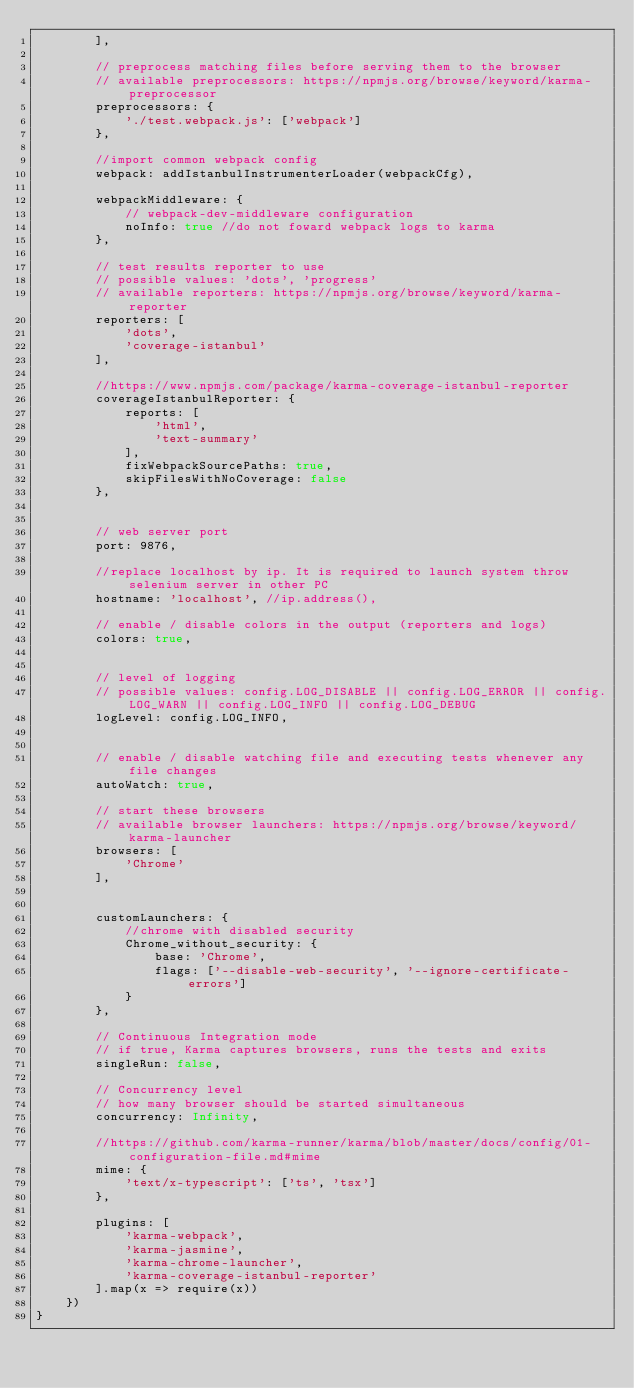<code> <loc_0><loc_0><loc_500><loc_500><_JavaScript_>        ],

        // preprocess matching files before serving them to the browser
        // available preprocessors: https://npmjs.org/browse/keyword/karma-preprocessor
        preprocessors: {
            './test.webpack.js': ['webpack']
        },

        //import common webpack config
        webpack: addIstanbulInstrumenterLoader(webpackCfg),

        webpackMiddleware: {
            // webpack-dev-middleware configuration
            noInfo: true //do not foward webpack logs to karma
        },

        // test results reporter to use
        // possible values: 'dots', 'progress'
        // available reporters: https://npmjs.org/browse/keyword/karma-reporter
        reporters: [
            'dots',
            'coverage-istanbul'
        ],

        //https://www.npmjs.com/package/karma-coverage-istanbul-reporter
        coverageIstanbulReporter: {
            reports: [
                'html',
                'text-summary'
            ],
            fixWebpackSourcePaths: true,
            skipFilesWithNoCoverage: false
        },


        // web server port
        port: 9876,

        //replace localhost by ip. It is required to launch system throw selenium server in other PC
        hostname: 'localhost', //ip.address(),

        // enable / disable colors in the output (reporters and logs)
        colors: true,


        // level of logging
        // possible values: config.LOG_DISABLE || config.LOG_ERROR || config.LOG_WARN || config.LOG_INFO || config.LOG_DEBUG
        logLevel: config.LOG_INFO,


        // enable / disable watching file and executing tests whenever any file changes
        autoWatch: true,

        // start these browsers
        // available browser launchers: https://npmjs.org/browse/keyword/karma-launcher
        browsers: [
            'Chrome'
        ],


        customLaunchers: {
            //chrome with disabled security
            Chrome_without_security: {
                base: 'Chrome',
                flags: ['--disable-web-security', '--ignore-certificate-errors']
            }
        },

        // Continuous Integration mode
        // if true, Karma captures browsers, runs the tests and exits
        singleRun: false,

        // Concurrency level
        // how many browser should be started simultaneous
        concurrency: Infinity,

        //https://github.com/karma-runner/karma/blob/master/docs/config/01-configuration-file.md#mime
        mime: {
            'text/x-typescript': ['ts', 'tsx']
        },

        plugins: [
            'karma-webpack',
            'karma-jasmine',
            'karma-chrome-launcher',
            'karma-coverage-istanbul-reporter'
        ].map(x => require(x))
    })
}
</code> 